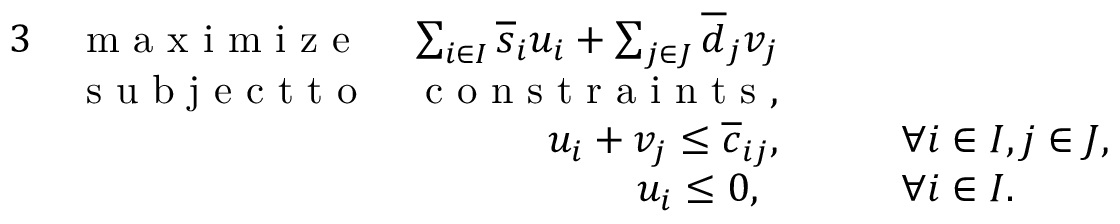<formula> <loc_0><loc_0><loc_500><loc_500>\begin{array} { r l r l } { 3 } & { \max i m i z e } & { \sum _ { i \in I } \overline { s } _ { i } u _ { i } + \sum _ { j \in J } \overline { d } _ { j } v _ { j } } \\ & { s u b j e c t t o } & { c o n s t r a i n t s , } \\ & { u _ { i } + v _ { j } \leq \overline { c } _ { i j } , } & { \quad \forall i \in I , j \in J , } \\ & { u _ { i } \leq 0 , \ \, } & { \quad \forall i \in I . } \end{array}</formula> 